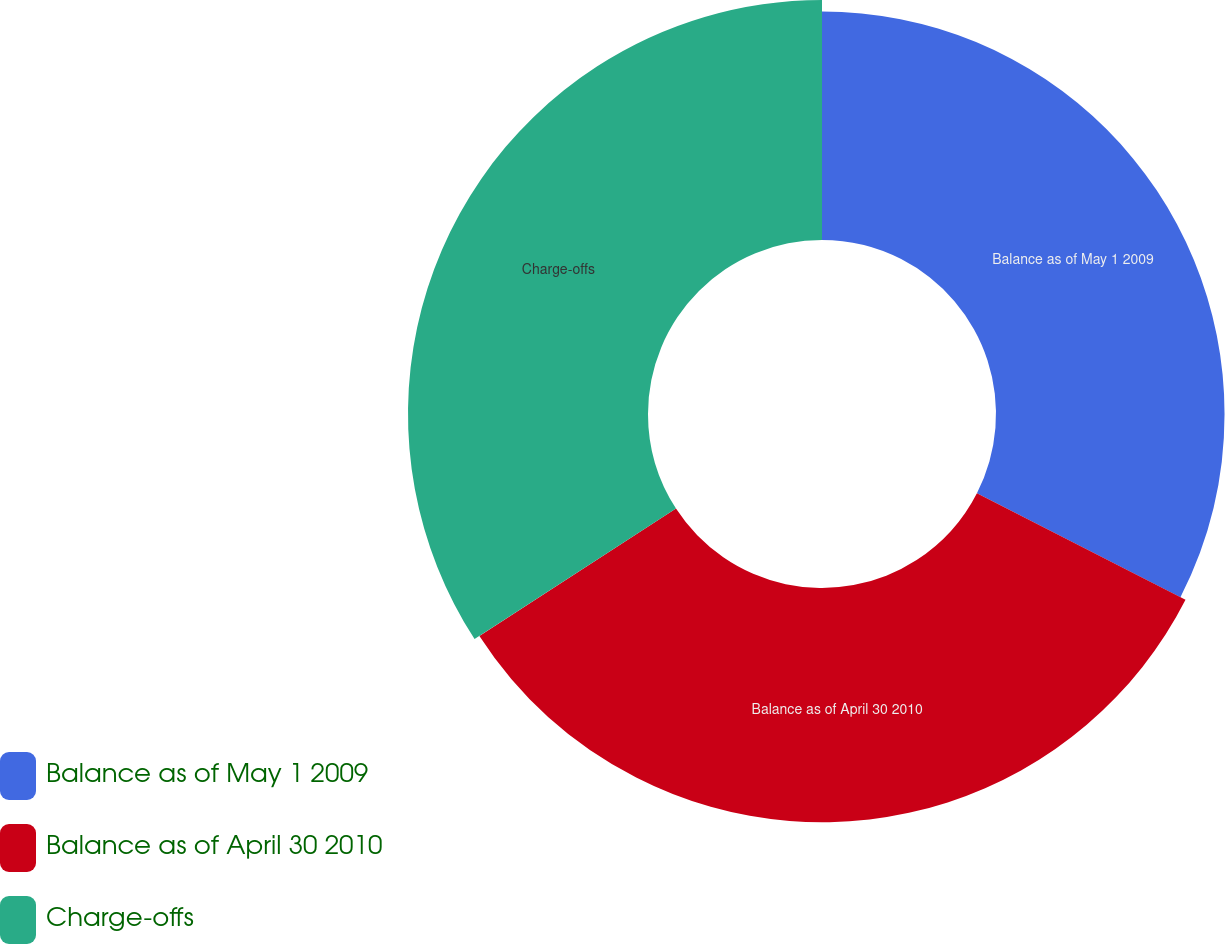Convert chart. <chart><loc_0><loc_0><loc_500><loc_500><pie_chart><fcel>Balance as of May 1 2009<fcel>Balance as of April 30 2010<fcel>Charge-offs<nl><fcel>32.52%<fcel>33.33%<fcel>34.15%<nl></chart> 